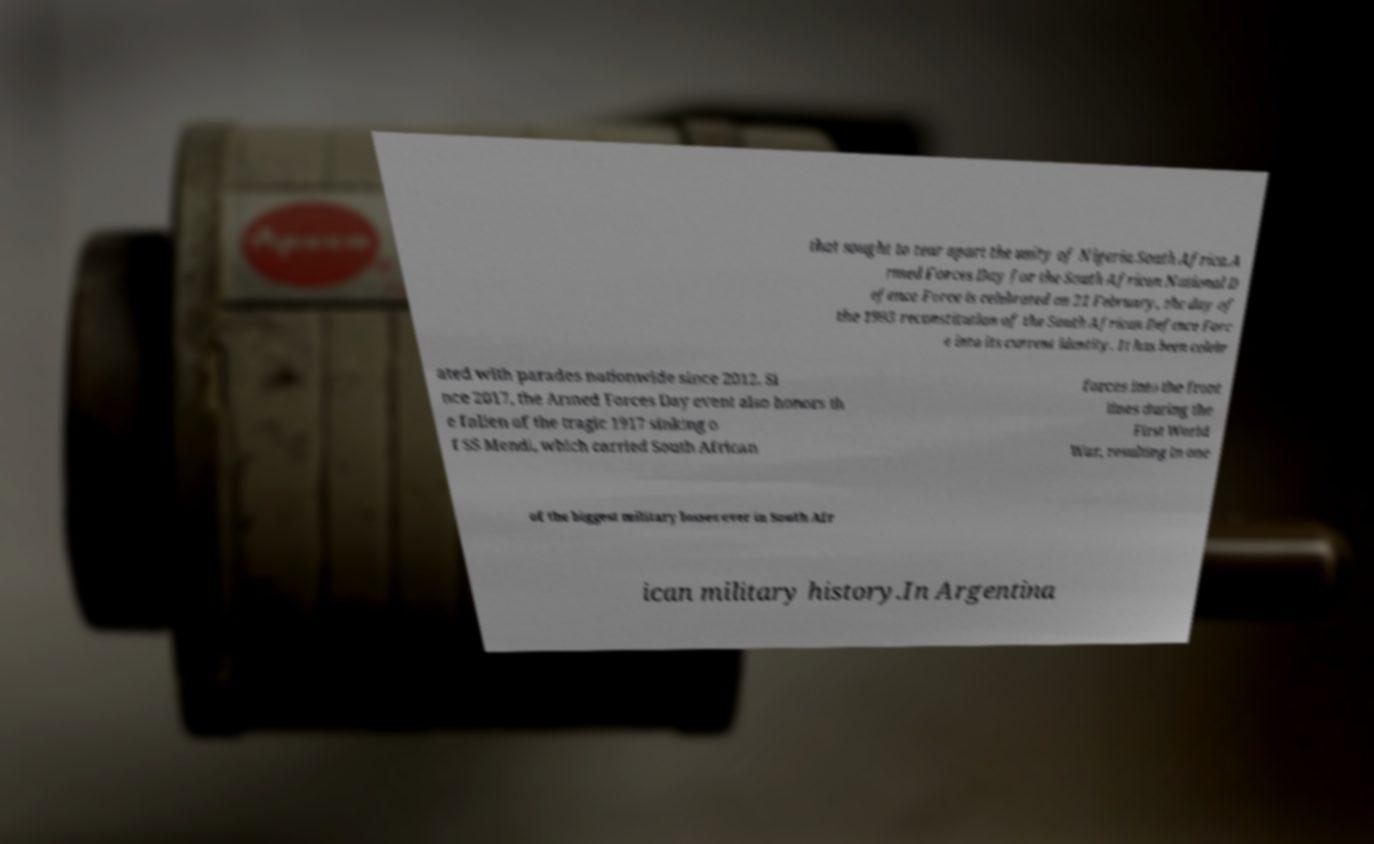Can you accurately transcribe the text from the provided image for me? that sought to tear apart the unity of Nigeria.South Africa.A rmed Forces Day for the South African National D efence Force is celebrated on 21 February, the day of the 1993 reconstitution of the South African Defence Forc e into its current identity. It has been celebr ated with parades nationwide since 2012. Si nce 2017, the Armed Forces Day event also honors th e fallen of the tragic 1917 sinking o f SS Mendi, which carried South African forces into the front lines during the First World War, resulting in one of the biggest military losses ever in South Afr ican military history.In Argentina 